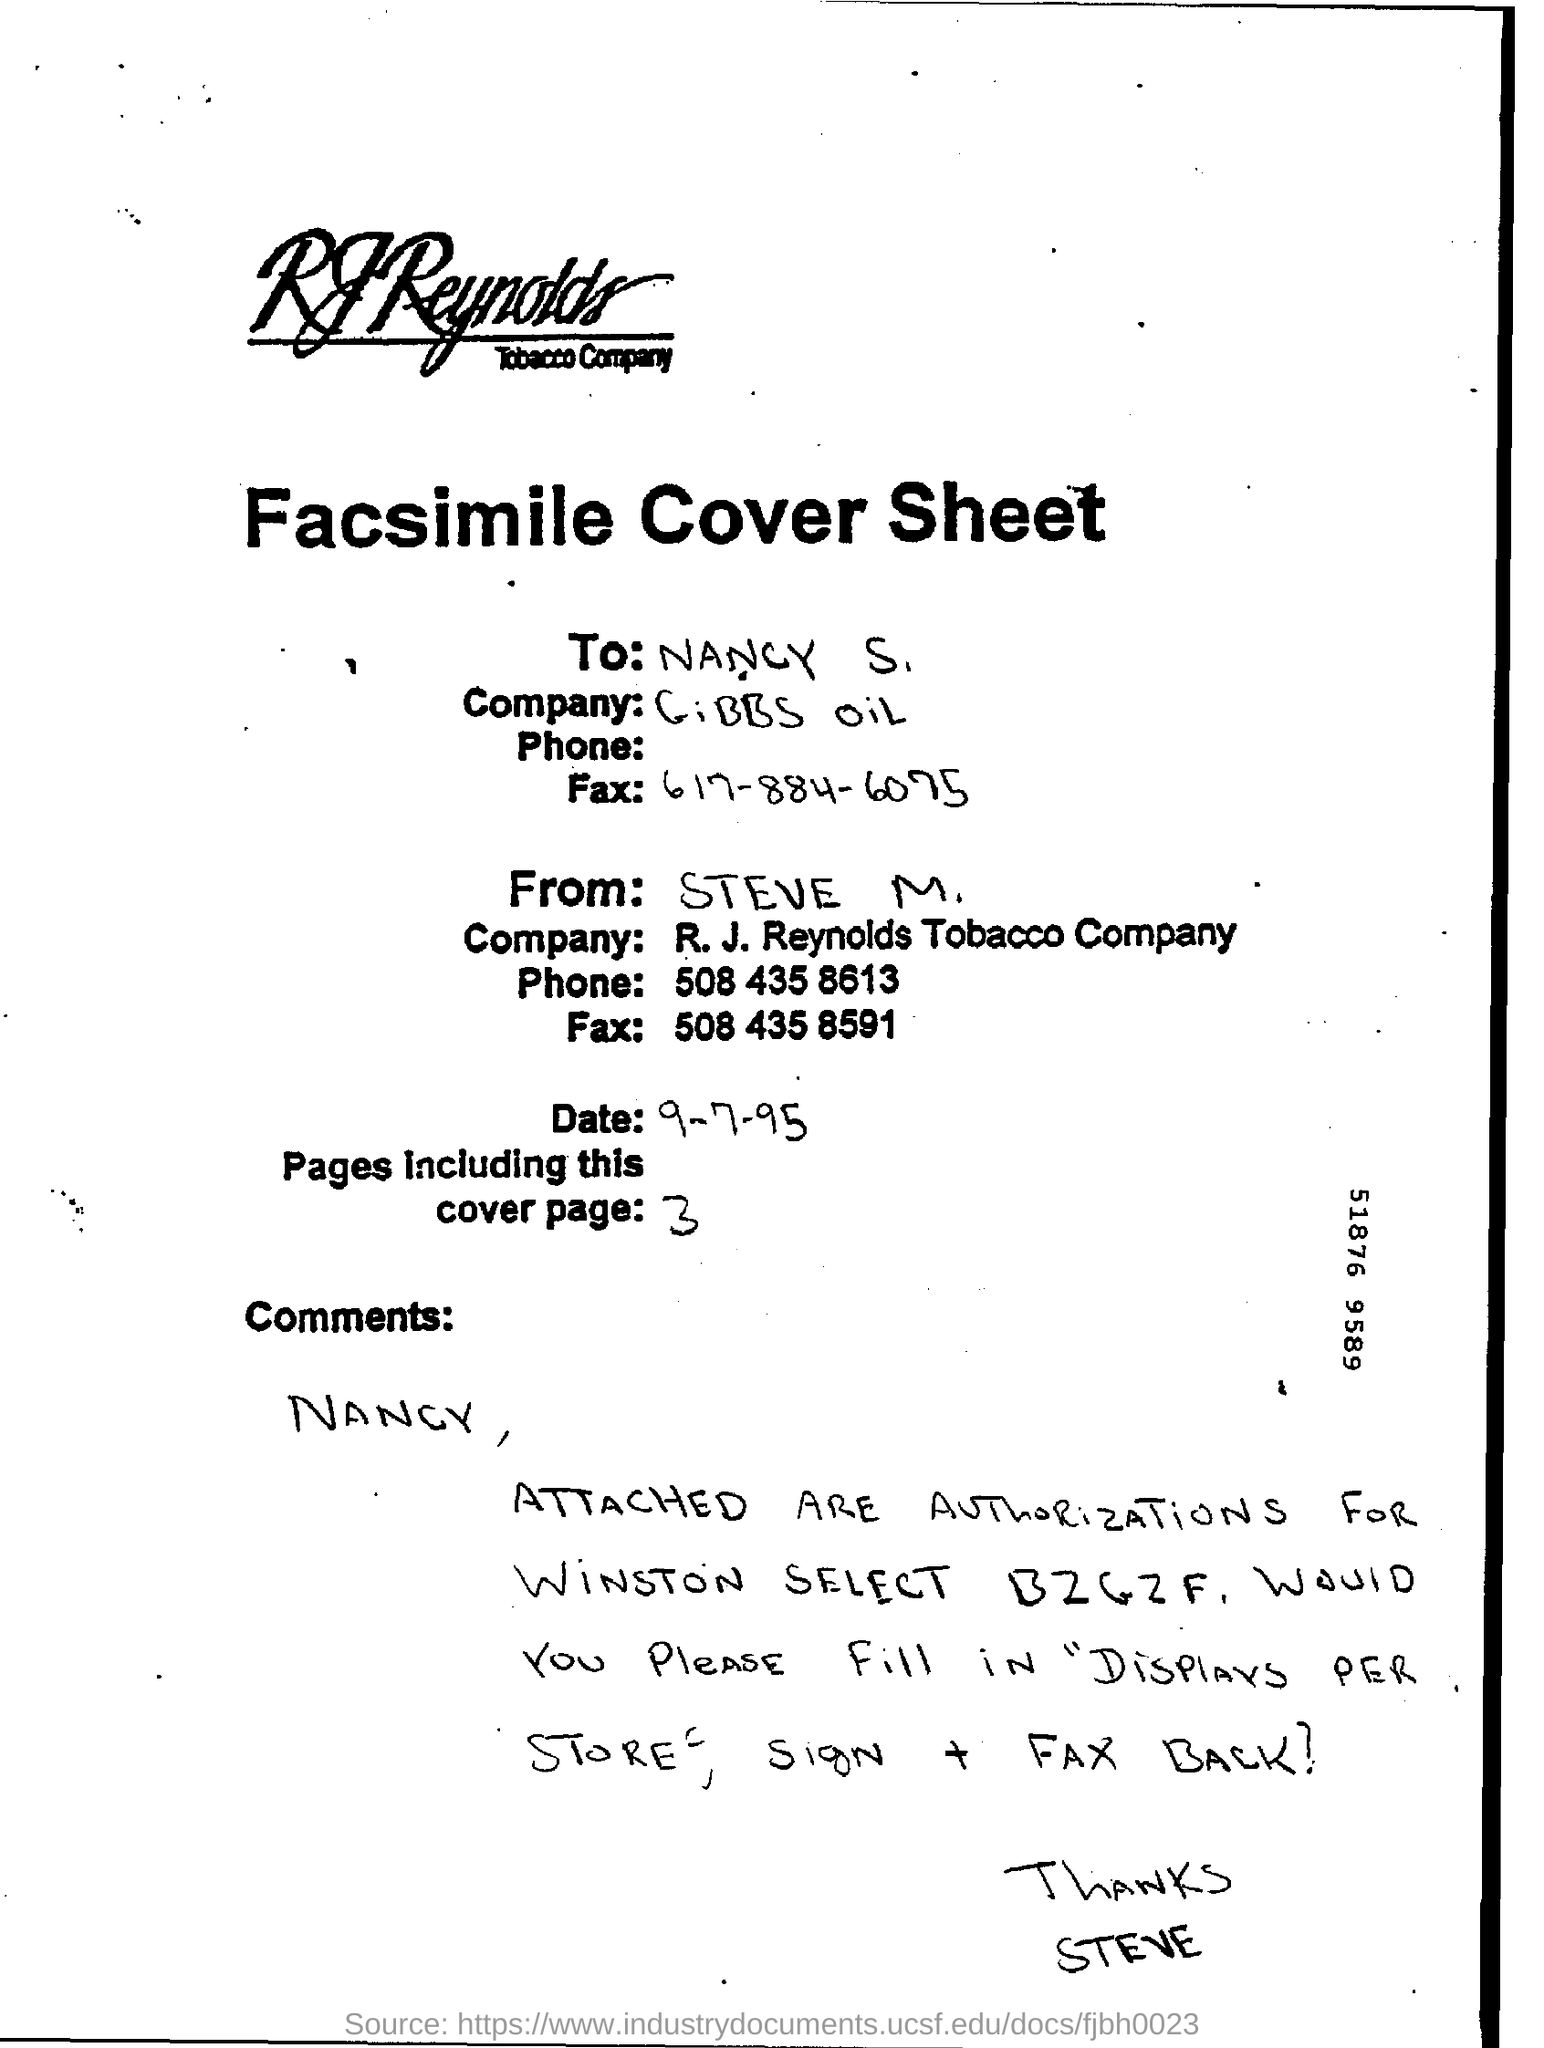How many total number of pages are mentioned in the sheet?
Your response must be concise. 3. When is the sheet dated?
Your answer should be compact. 9-7-95. Who is the sender of the Facsimile cover sheet?
Ensure brevity in your answer.  Steve M. To whom is the Facsimile cover sheet sent?
Ensure brevity in your answer.  Nancy S. 